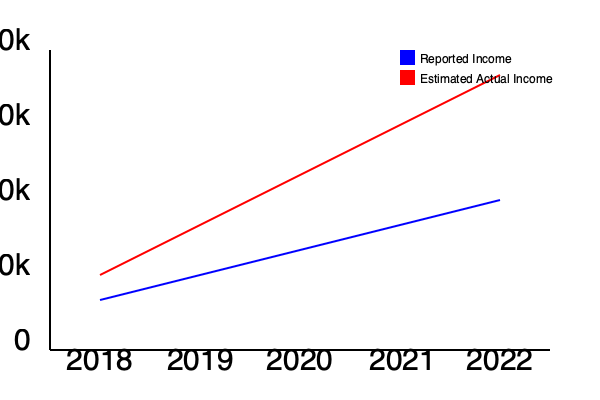As a government tax inspector, you've been monitoring a popular blogger's financial activities. The graph shows the blogger's reported income versus the estimated actual income over a 5-year period. Calculate the total estimated tax evasion amount for the entire period, assuming a flat tax rate of 30% on all income. Express your answer in dollars. To calculate the total estimated tax evasion amount, we need to follow these steps:

1. Calculate the difference between estimated actual income and reported income for each year:
   2018: $75,000 - $50,000 = $25,000
   2019: $125,000 - $75,000 = $50,000
   2020: $150,000 - $100,000 = $50,000
   2021: $175,000 - $125,000 = $50,000
   2022: $200,000 - $150,000 = $50,000

2. Sum up the differences for all years:
   $25,000 + $50,000 + $50,000 + $50,000 + $50,000 = $225,000

3. Apply the 30% tax rate to the total unreported income:
   $225,000 * 0.30 = $67,500

Therefore, the total estimated tax evasion amount for the entire period is $67,500.
Answer: $67,500 